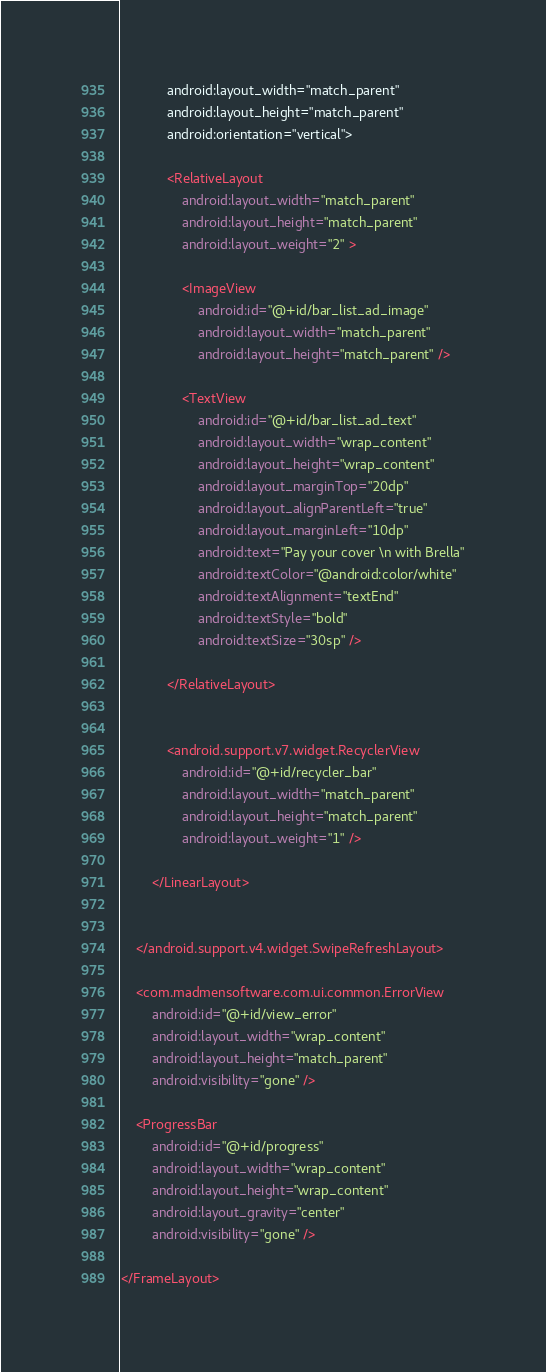<code> <loc_0><loc_0><loc_500><loc_500><_XML_>            android:layout_width="match_parent"
            android:layout_height="match_parent"
            android:orientation="vertical">

            <RelativeLayout
                android:layout_width="match_parent"
                android:layout_height="match_parent"
                android:layout_weight="2" >

                <ImageView
                    android:id="@+id/bar_list_ad_image"
                    android:layout_width="match_parent"
                    android:layout_height="match_parent" />

                <TextView
                    android:id="@+id/bar_list_ad_text"
                    android:layout_width="wrap_content"
                    android:layout_height="wrap_content"
                    android:layout_marginTop="20dp"
                    android:layout_alignParentLeft="true"
                    android:layout_marginLeft="10dp"
                    android:text="Pay your cover \n with Brella"
                    android:textColor="@android:color/white"
                    android:textAlignment="textEnd"
                    android:textStyle="bold"
                    android:textSize="30sp" />

            </RelativeLayout>


            <android.support.v7.widget.RecyclerView
                android:id="@+id/recycler_bar"
                android:layout_width="match_parent"
                android:layout_height="match_parent"
                android:layout_weight="1" />

        </LinearLayout>


    </android.support.v4.widget.SwipeRefreshLayout>

    <com.madmensoftware.com.ui.common.ErrorView
        android:id="@+id/view_error"
        android:layout_width="wrap_content"
        android:layout_height="match_parent"
        android:visibility="gone" />

    <ProgressBar
        android:id="@+id/progress"
        android:layout_width="wrap_content"
        android:layout_height="wrap_content"
        android:layout_gravity="center"
        android:visibility="gone" />

</FrameLayout>
</code> 